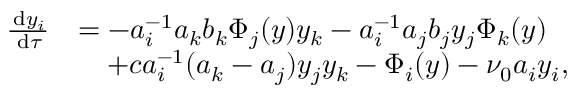Convert formula to latex. <formula><loc_0><loc_0><loc_500><loc_500>\begin{array} { r l } { \frac { \, d y _ { i } } { \, d \tau } } & { = - a _ { i } ^ { - 1 } a _ { k } b _ { k } \Phi _ { j } ( y ) y _ { k } - a _ { i } ^ { - 1 } a _ { j } b _ { j } y _ { j } \Phi _ { k } ( y ) } \\ & { \quad + c a _ { i } ^ { - 1 } ( a _ { k } - a _ { j } ) y _ { j } y _ { k } - \Phi _ { i } ( y ) - \nu _ { 0 } a _ { i } y _ { i } , } \end{array}</formula> 